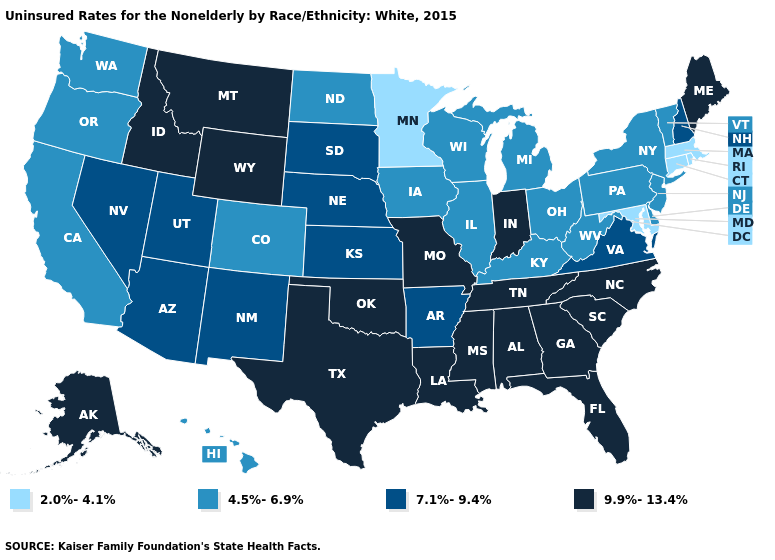Does the map have missing data?
Be succinct. No. What is the value of Rhode Island?
Answer briefly. 2.0%-4.1%. Among the states that border Ohio , which have the highest value?
Write a very short answer. Indiana. Does West Virginia have the highest value in the South?
Write a very short answer. No. Name the states that have a value in the range 2.0%-4.1%?
Keep it brief. Connecticut, Maryland, Massachusetts, Minnesota, Rhode Island. Does Connecticut have the same value as Maryland?
Concise answer only. Yes. What is the value of California?
Give a very brief answer. 4.5%-6.9%. What is the highest value in states that border Oregon?
Quick response, please. 9.9%-13.4%. What is the value of Alabama?
Keep it brief. 9.9%-13.4%. Name the states that have a value in the range 9.9%-13.4%?
Quick response, please. Alabama, Alaska, Florida, Georgia, Idaho, Indiana, Louisiana, Maine, Mississippi, Missouri, Montana, North Carolina, Oklahoma, South Carolina, Tennessee, Texas, Wyoming. What is the lowest value in states that border Tennessee?
Be succinct. 4.5%-6.9%. Which states have the highest value in the USA?
Short answer required. Alabama, Alaska, Florida, Georgia, Idaho, Indiana, Louisiana, Maine, Mississippi, Missouri, Montana, North Carolina, Oklahoma, South Carolina, Tennessee, Texas, Wyoming. How many symbols are there in the legend?
Answer briefly. 4. Name the states that have a value in the range 2.0%-4.1%?
Write a very short answer. Connecticut, Maryland, Massachusetts, Minnesota, Rhode Island. What is the value of Nevada?
Quick response, please. 7.1%-9.4%. 